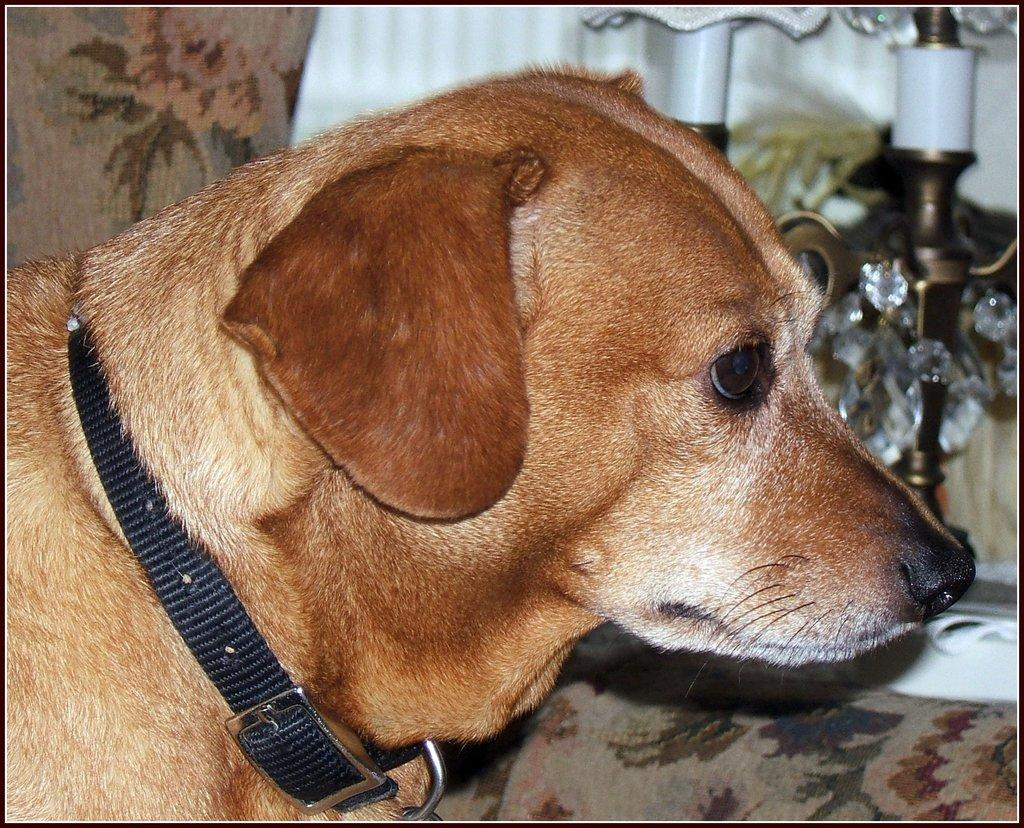What animal can be seen in the image? There is a dog in the image. What is the dog wearing? The dog is wearing a belt. Where is the dog located in the image? The dog is on a couch. What can be seen in the background of the image? There are lights and a curtain in the background of the image. What news channel is the dog watching on the television in the image? There is no television or text present in the image, so it is not possible to determine what news channel the dog might be watching. 